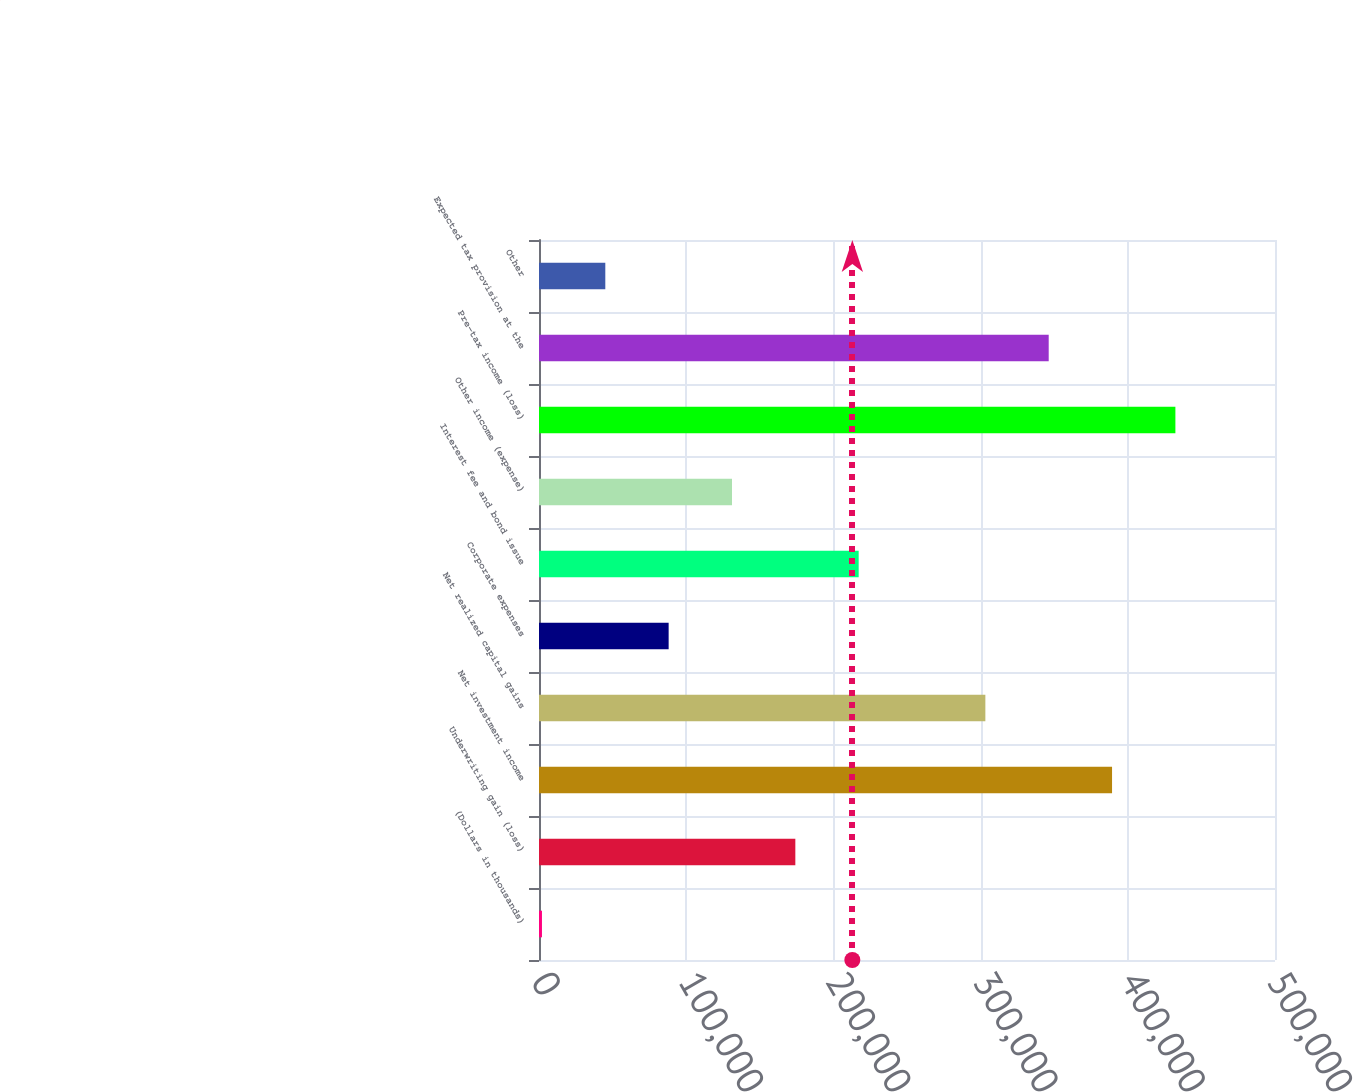<chart> <loc_0><loc_0><loc_500><loc_500><bar_chart><fcel>(Dollars in thousands)<fcel>Underwriting gain (loss)<fcel>Net investment income<fcel>Net realized capital gains<fcel>Corporate expenses<fcel>Interest fee and bond issue<fcel>Other income (expense)<fcel>Pre-tax income (loss)<fcel>Expected tax provision at the<fcel>Other<nl><fcel>2012<fcel>174140<fcel>389300<fcel>303236<fcel>88076<fcel>217172<fcel>131108<fcel>432332<fcel>346268<fcel>45044<nl></chart> 